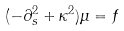<formula> <loc_0><loc_0><loc_500><loc_500>( - \partial _ { s } ^ { 2 } + \kappa ^ { 2 } ) \mu = f</formula> 